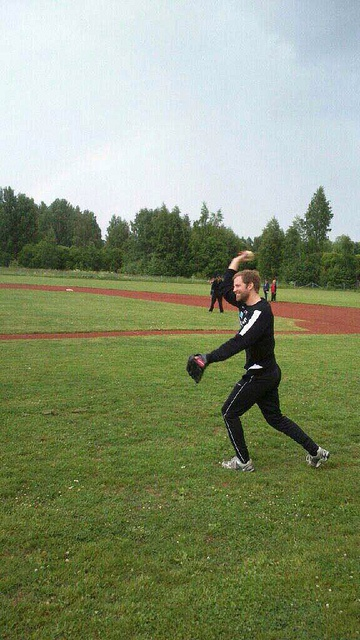Describe the objects in this image and their specific colors. I can see people in white, black, darkgreen, gray, and olive tones, baseball glove in white, black, gray, darkgreen, and brown tones, people in white, black, gray, and maroon tones, people in white, black, olive, brown, and maroon tones, and people in white, black, gray, darkgray, and navy tones in this image. 